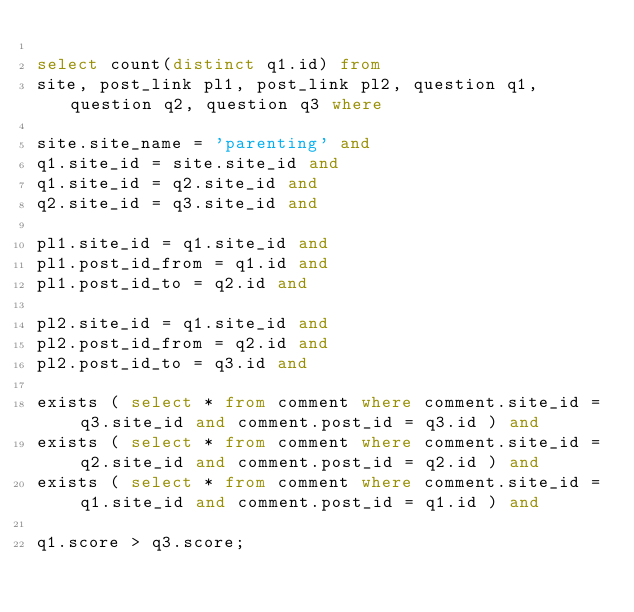Convert code to text. <code><loc_0><loc_0><loc_500><loc_500><_SQL_>
select count(distinct q1.id) from
site, post_link pl1, post_link pl2, question q1, question q2, question q3 where

site.site_name = 'parenting' and
q1.site_id = site.site_id and
q1.site_id = q2.site_id and
q2.site_id = q3.site_id and

pl1.site_id = q1.site_id and
pl1.post_id_from = q1.id and
pl1.post_id_to = q2.id and

pl2.site_id = q1.site_id and
pl2.post_id_from = q2.id and
pl2.post_id_to = q3.id and

exists ( select * from comment where comment.site_id = q3.site_id and comment.post_id = q3.id ) and
exists ( select * from comment where comment.site_id = q2.site_id and comment.post_id = q2.id ) and
exists ( select * from comment where comment.site_id = q1.site_id and comment.post_id = q1.id ) and

q1.score > q3.score;
</code> 